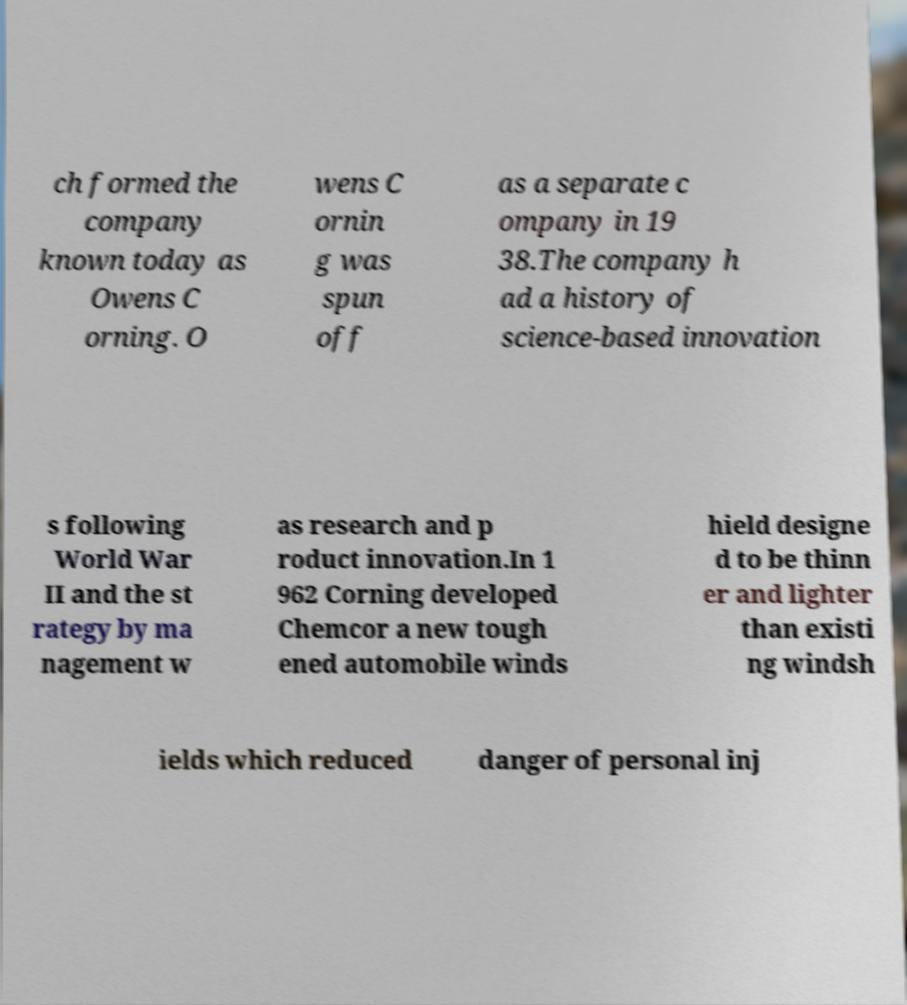Could you assist in decoding the text presented in this image and type it out clearly? ch formed the company known today as Owens C orning. O wens C ornin g was spun off as a separate c ompany in 19 38.The company h ad a history of science-based innovation s following World War II and the st rategy by ma nagement w as research and p roduct innovation.In 1 962 Corning developed Chemcor a new tough ened automobile winds hield designe d to be thinn er and lighter than existi ng windsh ields which reduced danger of personal inj 